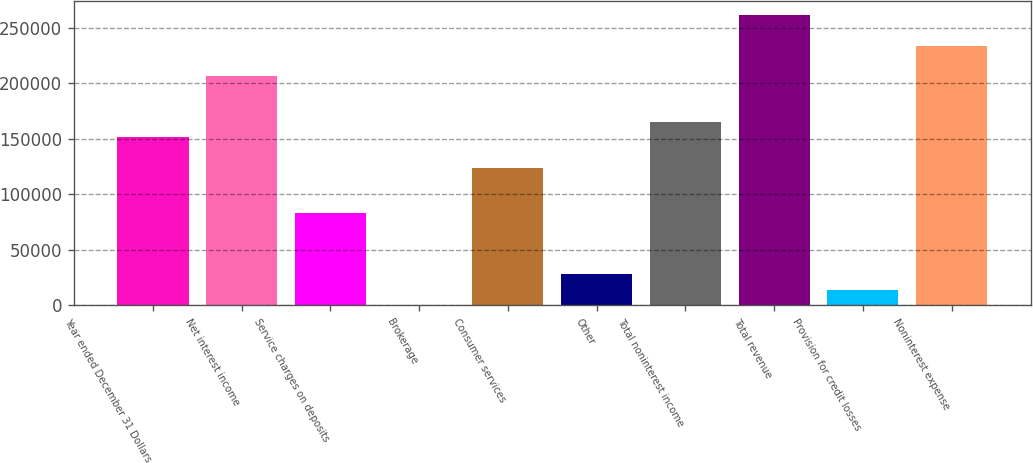Convert chart. <chart><loc_0><loc_0><loc_500><loc_500><bar_chart><fcel>Year ended December 31 Dollars<fcel>Net interest income<fcel>Service charges on deposits<fcel>Brokerage<fcel>Consumer services<fcel>Other<fcel>Total noninterest income<fcel>Total revenue<fcel>Provision for credit losses<fcel>Noninterest expense<nl><fcel>151421<fcel>206396<fcel>82702.2<fcel>240<fcel>123933<fcel>27727.4<fcel>165164<fcel>261370<fcel>13983.7<fcel>233883<nl></chart> 